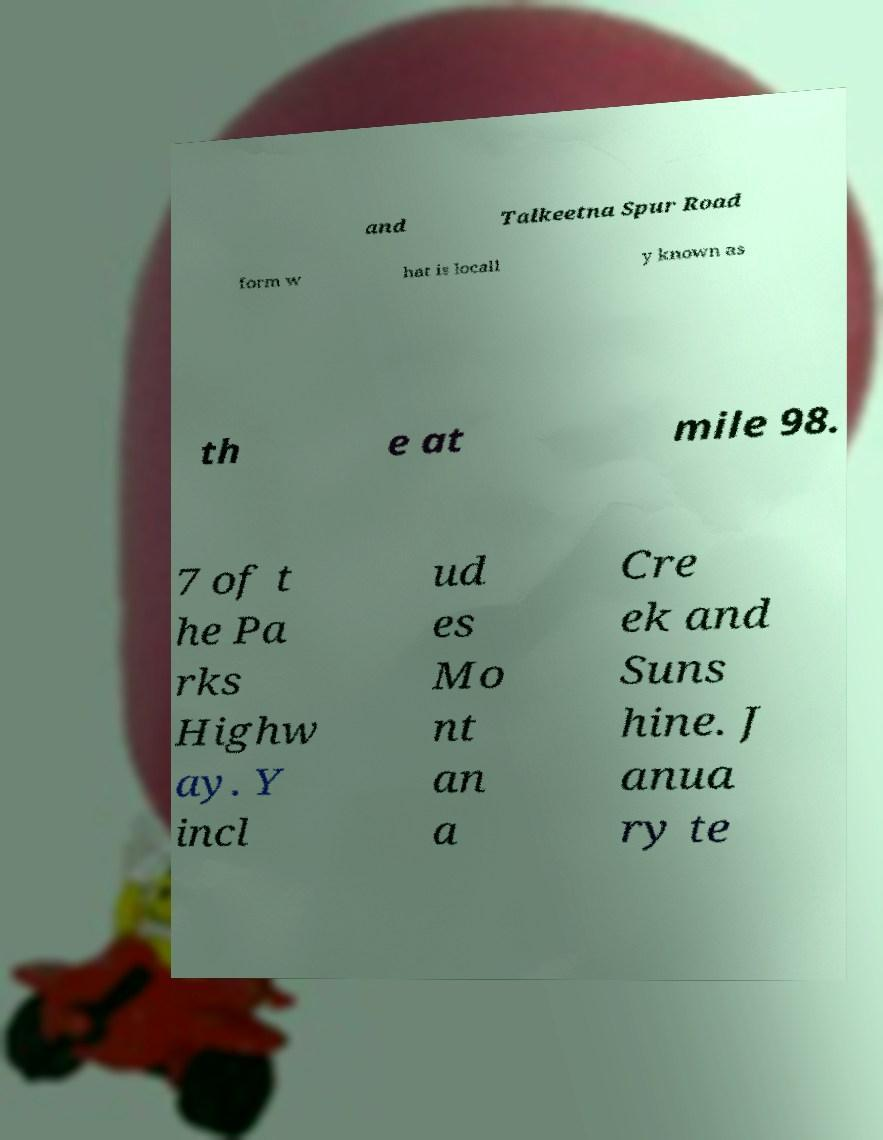Please identify and transcribe the text found in this image. and Talkeetna Spur Road form w hat is locall y known as th e at mile 98. 7 of t he Pa rks Highw ay. Y incl ud es Mo nt an a Cre ek and Suns hine. J anua ry te 